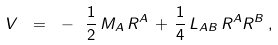<formula> <loc_0><loc_0><loc_500><loc_500>V \ = \ - \ \frac { 1 } { 2 } \, M _ { A } \, R ^ { A } \, + \, \frac { 1 } { 4 } \, L _ { A B } \, R ^ { A } R ^ { B } \, ,</formula> 